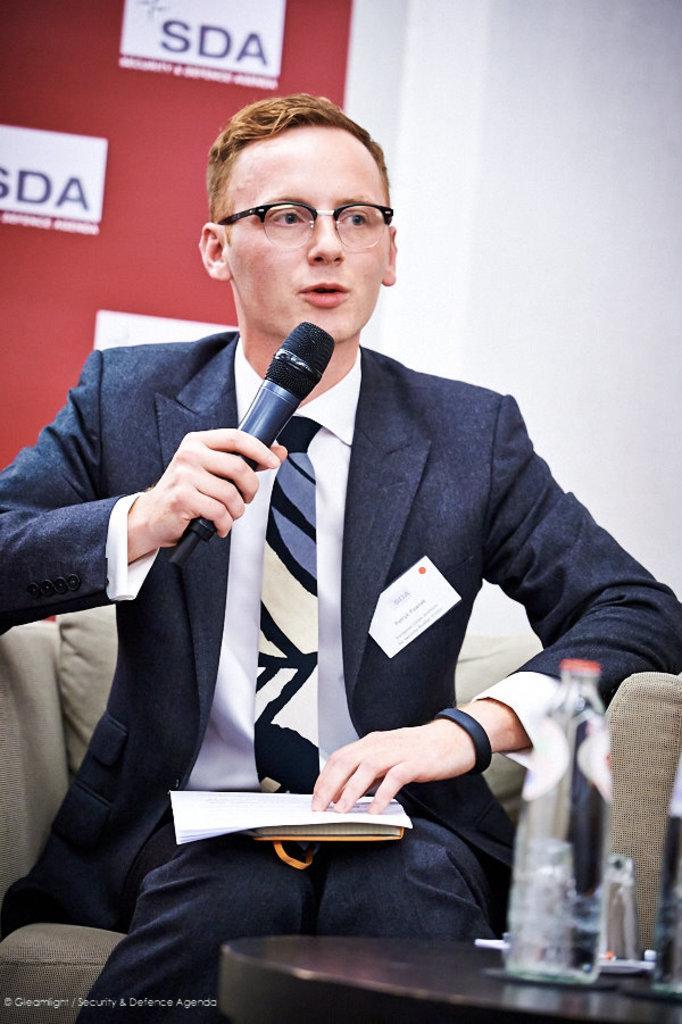Could you give a brief overview of what you see in this image? In this picture we can see a person sitting on a chair and holding a microphone in his hand and speaking ,and in front there is the table and water bottle on it, and at the back there is the wall. 